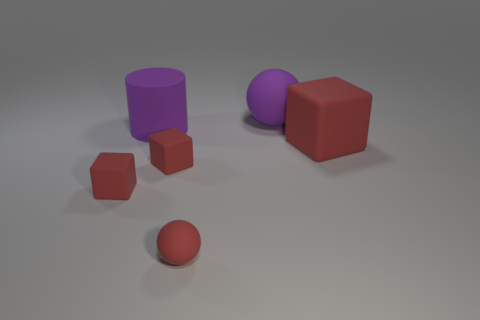Add 2 big green shiny cylinders. How many objects exist? 8 Subtract all cylinders. How many objects are left? 5 Subtract 1 purple balls. How many objects are left? 5 Subtract all red balls. Subtract all big things. How many objects are left? 2 Add 1 small red matte spheres. How many small red matte spheres are left? 2 Add 3 big purple spheres. How many big purple spheres exist? 4 